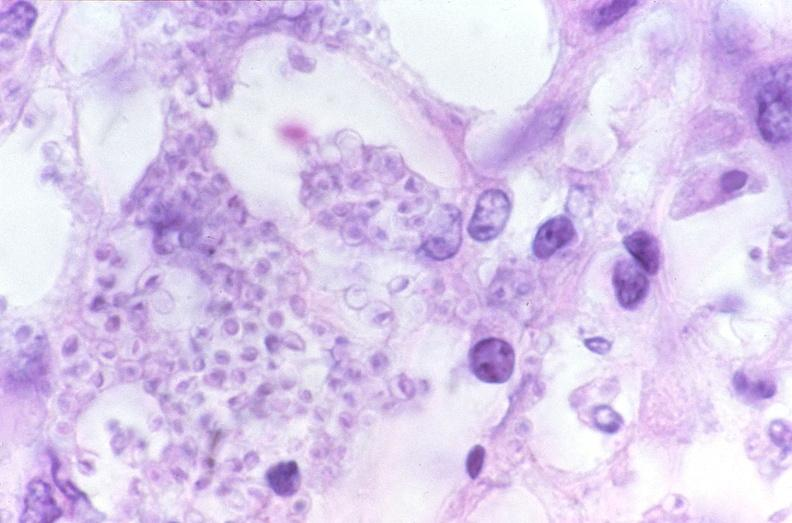s respiratory present?
Answer the question using a single word or phrase. Yes 